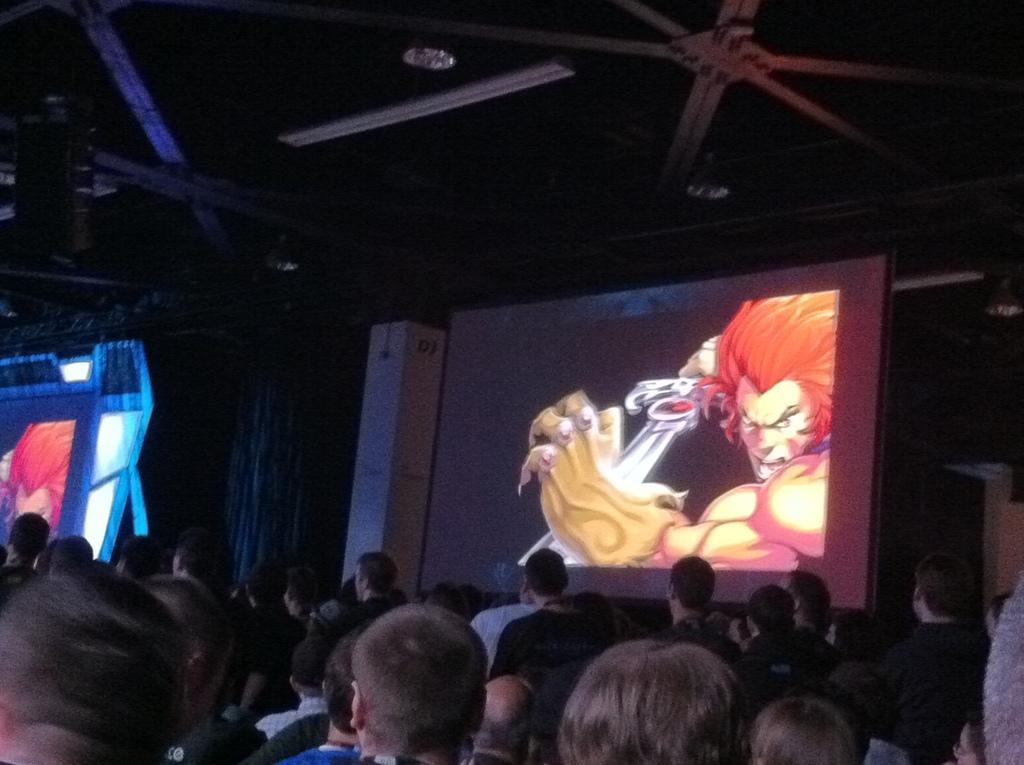Can you describe this image briefly? In this image we can see a few people, there we can see a screen with a cartoon picture of a person holding a sword, there we can also see some lights to the roof. 